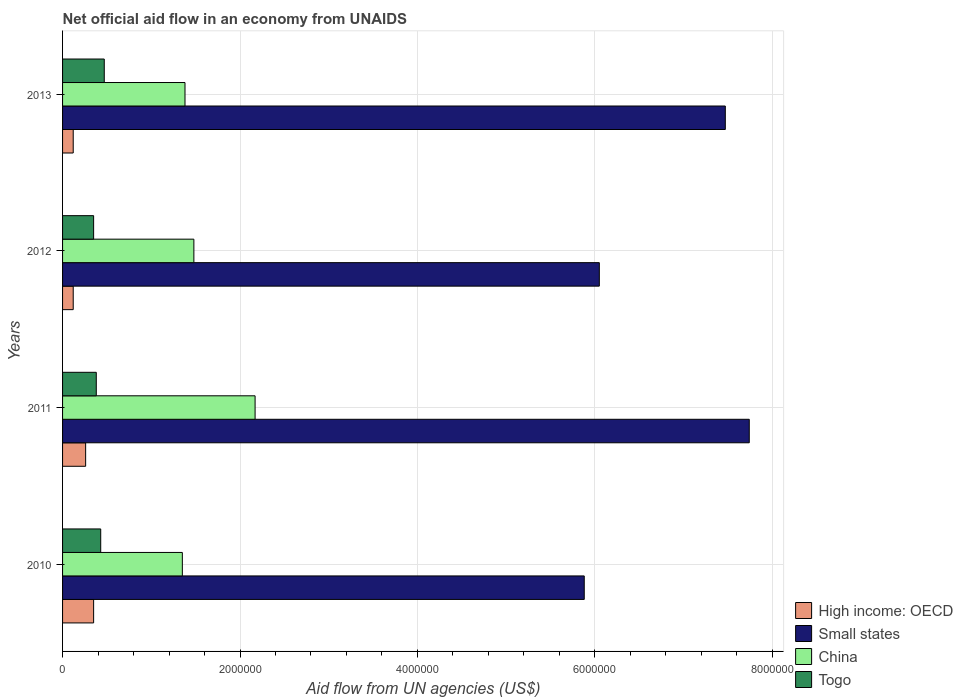Are the number of bars per tick equal to the number of legend labels?
Give a very brief answer. Yes. How many bars are there on the 1st tick from the top?
Provide a short and direct response. 4. How many bars are there on the 2nd tick from the bottom?
Provide a succinct answer. 4. In how many cases, is the number of bars for a given year not equal to the number of legend labels?
Provide a short and direct response. 0. What is the net official aid flow in High income: OECD in 2011?
Keep it short and to the point. 2.60e+05. Across all years, what is the maximum net official aid flow in High income: OECD?
Your answer should be compact. 3.50e+05. Across all years, what is the minimum net official aid flow in High income: OECD?
Your answer should be very brief. 1.20e+05. In which year was the net official aid flow in Small states maximum?
Ensure brevity in your answer.  2011. What is the total net official aid flow in Small states in the graph?
Your answer should be very brief. 2.71e+07. What is the difference between the net official aid flow in China in 2010 and that in 2012?
Ensure brevity in your answer.  -1.30e+05. What is the difference between the net official aid flow in Togo in 2011 and the net official aid flow in Small states in 2012?
Provide a succinct answer. -5.67e+06. What is the average net official aid flow in China per year?
Make the answer very short. 1.60e+06. In the year 2011, what is the difference between the net official aid flow in China and net official aid flow in High income: OECD?
Your answer should be very brief. 1.91e+06. What is the ratio of the net official aid flow in Small states in 2011 to that in 2012?
Your response must be concise. 1.28. What is the difference between the highest and the second highest net official aid flow in High income: OECD?
Offer a terse response. 9.00e+04. What is the difference between the highest and the lowest net official aid flow in China?
Offer a very short reply. 8.20e+05. Is it the case that in every year, the sum of the net official aid flow in Togo and net official aid flow in Small states is greater than the sum of net official aid flow in High income: OECD and net official aid flow in China?
Your answer should be compact. Yes. What does the 1st bar from the top in 2012 represents?
Keep it short and to the point. Togo. What does the 2nd bar from the bottom in 2012 represents?
Make the answer very short. Small states. Are all the bars in the graph horizontal?
Provide a short and direct response. Yes. How many years are there in the graph?
Give a very brief answer. 4. What is the difference between two consecutive major ticks on the X-axis?
Keep it short and to the point. 2.00e+06. Does the graph contain any zero values?
Keep it short and to the point. No. Does the graph contain grids?
Your response must be concise. Yes. Where does the legend appear in the graph?
Keep it short and to the point. Bottom right. How many legend labels are there?
Your response must be concise. 4. What is the title of the graph?
Provide a succinct answer. Net official aid flow in an economy from UNAIDS. What is the label or title of the X-axis?
Give a very brief answer. Aid flow from UN agencies (US$). What is the Aid flow from UN agencies (US$) in Small states in 2010?
Your answer should be very brief. 5.88e+06. What is the Aid flow from UN agencies (US$) of China in 2010?
Your response must be concise. 1.35e+06. What is the Aid flow from UN agencies (US$) in Togo in 2010?
Ensure brevity in your answer.  4.30e+05. What is the Aid flow from UN agencies (US$) in Small states in 2011?
Provide a short and direct response. 7.74e+06. What is the Aid flow from UN agencies (US$) of China in 2011?
Offer a very short reply. 2.17e+06. What is the Aid flow from UN agencies (US$) in Small states in 2012?
Give a very brief answer. 6.05e+06. What is the Aid flow from UN agencies (US$) of China in 2012?
Ensure brevity in your answer.  1.48e+06. What is the Aid flow from UN agencies (US$) of Small states in 2013?
Make the answer very short. 7.47e+06. What is the Aid flow from UN agencies (US$) in China in 2013?
Your answer should be compact. 1.38e+06. Across all years, what is the maximum Aid flow from UN agencies (US$) in High income: OECD?
Provide a succinct answer. 3.50e+05. Across all years, what is the maximum Aid flow from UN agencies (US$) of Small states?
Your answer should be compact. 7.74e+06. Across all years, what is the maximum Aid flow from UN agencies (US$) of China?
Keep it short and to the point. 2.17e+06. Across all years, what is the minimum Aid flow from UN agencies (US$) of High income: OECD?
Make the answer very short. 1.20e+05. Across all years, what is the minimum Aid flow from UN agencies (US$) of Small states?
Keep it short and to the point. 5.88e+06. Across all years, what is the minimum Aid flow from UN agencies (US$) of China?
Ensure brevity in your answer.  1.35e+06. Across all years, what is the minimum Aid flow from UN agencies (US$) in Togo?
Provide a short and direct response. 3.50e+05. What is the total Aid flow from UN agencies (US$) in High income: OECD in the graph?
Provide a short and direct response. 8.50e+05. What is the total Aid flow from UN agencies (US$) in Small states in the graph?
Provide a succinct answer. 2.71e+07. What is the total Aid flow from UN agencies (US$) in China in the graph?
Keep it short and to the point. 6.38e+06. What is the total Aid flow from UN agencies (US$) of Togo in the graph?
Ensure brevity in your answer.  1.63e+06. What is the difference between the Aid flow from UN agencies (US$) in High income: OECD in 2010 and that in 2011?
Keep it short and to the point. 9.00e+04. What is the difference between the Aid flow from UN agencies (US$) in Small states in 2010 and that in 2011?
Give a very brief answer. -1.86e+06. What is the difference between the Aid flow from UN agencies (US$) in China in 2010 and that in 2011?
Provide a succinct answer. -8.20e+05. What is the difference between the Aid flow from UN agencies (US$) in Togo in 2010 and that in 2011?
Provide a short and direct response. 5.00e+04. What is the difference between the Aid flow from UN agencies (US$) in Small states in 2010 and that in 2012?
Your answer should be compact. -1.70e+05. What is the difference between the Aid flow from UN agencies (US$) in China in 2010 and that in 2012?
Offer a terse response. -1.30e+05. What is the difference between the Aid flow from UN agencies (US$) in High income: OECD in 2010 and that in 2013?
Make the answer very short. 2.30e+05. What is the difference between the Aid flow from UN agencies (US$) of Small states in 2010 and that in 2013?
Provide a short and direct response. -1.59e+06. What is the difference between the Aid flow from UN agencies (US$) in High income: OECD in 2011 and that in 2012?
Ensure brevity in your answer.  1.40e+05. What is the difference between the Aid flow from UN agencies (US$) of Small states in 2011 and that in 2012?
Keep it short and to the point. 1.69e+06. What is the difference between the Aid flow from UN agencies (US$) in China in 2011 and that in 2012?
Provide a succinct answer. 6.90e+05. What is the difference between the Aid flow from UN agencies (US$) of High income: OECD in 2011 and that in 2013?
Provide a succinct answer. 1.40e+05. What is the difference between the Aid flow from UN agencies (US$) in Small states in 2011 and that in 2013?
Your response must be concise. 2.70e+05. What is the difference between the Aid flow from UN agencies (US$) in China in 2011 and that in 2013?
Provide a short and direct response. 7.90e+05. What is the difference between the Aid flow from UN agencies (US$) in Togo in 2011 and that in 2013?
Offer a very short reply. -9.00e+04. What is the difference between the Aid flow from UN agencies (US$) of High income: OECD in 2012 and that in 2013?
Provide a short and direct response. 0. What is the difference between the Aid flow from UN agencies (US$) in Small states in 2012 and that in 2013?
Offer a terse response. -1.42e+06. What is the difference between the Aid flow from UN agencies (US$) in China in 2012 and that in 2013?
Make the answer very short. 1.00e+05. What is the difference between the Aid flow from UN agencies (US$) in Togo in 2012 and that in 2013?
Make the answer very short. -1.20e+05. What is the difference between the Aid flow from UN agencies (US$) in High income: OECD in 2010 and the Aid flow from UN agencies (US$) in Small states in 2011?
Offer a very short reply. -7.39e+06. What is the difference between the Aid flow from UN agencies (US$) in High income: OECD in 2010 and the Aid flow from UN agencies (US$) in China in 2011?
Your answer should be very brief. -1.82e+06. What is the difference between the Aid flow from UN agencies (US$) in Small states in 2010 and the Aid flow from UN agencies (US$) in China in 2011?
Your response must be concise. 3.71e+06. What is the difference between the Aid flow from UN agencies (US$) in Small states in 2010 and the Aid flow from UN agencies (US$) in Togo in 2011?
Offer a very short reply. 5.50e+06. What is the difference between the Aid flow from UN agencies (US$) of China in 2010 and the Aid flow from UN agencies (US$) of Togo in 2011?
Offer a terse response. 9.70e+05. What is the difference between the Aid flow from UN agencies (US$) in High income: OECD in 2010 and the Aid flow from UN agencies (US$) in Small states in 2012?
Provide a succinct answer. -5.70e+06. What is the difference between the Aid flow from UN agencies (US$) in High income: OECD in 2010 and the Aid flow from UN agencies (US$) in China in 2012?
Give a very brief answer. -1.13e+06. What is the difference between the Aid flow from UN agencies (US$) in Small states in 2010 and the Aid flow from UN agencies (US$) in China in 2012?
Ensure brevity in your answer.  4.40e+06. What is the difference between the Aid flow from UN agencies (US$) in Small states in 2010 and the Aid flow from UN agencies (US$) in Togo in 2012?
Ensure brevity in your answer.  5.53e+06. What is the difference between the Aid flow from UN agencies (US$) of China in 2010 and the Aid flow from UN agencies (US$) of Togo in 2012?
Offer a very short reply. 1.00e+06. What is the difference between the Aid flow from UN agencies (US$) of High income: OECD in 2010 and the Aid flow from UN agencies (US$) of Small states in 2013?
Keep it short and to the point. -7.12e+06. What is the difference between the Aid flow from UN agencies (US$) in High income: OECD in 2010 and the Aid flow from UN agencies (US$) in China in 2013?
Provide a succinct answer. -1.03e+06. What is the difference between the Aid flow from UN agencies (US$) in High income: OECD in 2010 and the Aid flow from UN agencies (US$) in Togo in 2013?
Your answer should be compact. -1.20e+05. What is the difference between the Aid flow from UN agencies (US$) in Small states in 2010 and the Aid flow from UN agencies (US$) in China in 2013?
Provide a succinct answer. 4.50e+06. What is the difference between the Aid flow from UN agencies (US$) of Small states in 2010 and the Aid flow from UN agencies (US$) of Togo in 2013?
Give a very brief answer. 5.41e+06. What is the difference between the Aid flow from UN agencies (US$) of China in 2010 and the Aid flow from UN agencies (US$) of Togo in 2013?
Your response must be concise. 8.80e+05. What is the difference between the Aid flow from UN agencies (US$) of High income: OECD in 2011 and the Aid flow from UN agencies (US$) of Small states in 2012?
Provide a succinct answer. -5.79e+06. What is the difference between the Aid flow from UN agencies (US$) in High income: OECD in 2011 and the Aid flow from UN agencies (US$) in China in 2012?
Provide a succinct answer. -1.22e+06. What is the difference between the Aid flow from UN agencies (US$) in Small states in 2011 and the Aid flow from UN agencies (US$) in China in 2012?
Give a very brief answer. 6.26e+06. What is the difference between the Aid flow from UN agencies (US$) of Small states in 2011 and the Aid flow from UN agencies (US$) of Togo in 2012?
Provide a short and direct response. 7.39e+06. What is the difference between the Aid flow from UN agencies (US$) in China in 2011 and the Aid flow from UN agencies (US$) in Togo in 2012?
Ensure brevity in your answer.  1.82e+06. What is the difference between the Aid flow from UN agencies (US$) in High income: OECD in 2011 and the Aid flow from UN agencies (US$) in Small states in 2013?
Your answer should be compact. -7.21e+06. What is the difference between the Aid flow from UN agencies (US$) in High income: OECD in 2011 and the Aid flow from UN agencies (US$) in China in 2013?
Ensure brevity in your answer.  -1.12e+06. What is the difference between the Aid flow from UN agencies (US$) of High income: OECD in 2011 and the Aid flow from UN agencies (US$) of Togo in 2013?
Your answer should be very brief. -2.10e+05. What is the difference between the Aid flow from UN agencies (US$) of Small states in 2011 and the Aid flow from UN agencies (US$) of China in 2013?
Your answer should be very brief. 6.36e+06. What is the difference between the Aid flow from UN agencies (US$) in Small states in 2011 and the Aid flow from UN agencies (US$) in Togo in 2013?
Give a very brief answer. 7.27e+06. What is the difference between the Aid flow from UN agencies (US$) of China in 2011 and the Aid flow from UN agencies (US$) of Togo in 2013?
Your answer should be compact. 1.70e+06. What is the difference between the Aid flow from UN agencies (US$) of High income: OECD in 2012 and the Aid flow from UN agencies (US$) of Small states in 2013?
Provide a succinct answer. -7.35e+06. What is the difference between the Aid flow from UN agencies (US$) of High income: OECD in 2012 and the Aid flow from UN agencies (US$) of China in 2013?
Your response must be concise. -1.26e+06. What is the difference between the Aid flow from UN agencies (US$) in High income: OECD in 2012 and the Aid flow from UN agencies (US$) in Togo in 2013?
Provide a succinct answer. -3.50e+05. What is the difference between the Aid flow from UN agencies (US$) in Small states in 2012 and the Aid flow from UN agencies (US$) in China in 2013?
Your answer should be very brief. 4.67e+06. What is the difference between the Aid flow from UN agencies (US$) of Small states in 2012 and the Aid flow from UN agencies (US$) of Togo in 2013?
Your answer should be very brief. 5.58e+06. What is the difference between the Aid flow from UN agencies (US$) in China in 2012 and the Aid flow from UN agencies (US$) in Togo in 2013?
Your answer should be compact. 1.01e+06. What is the average Aid flow from UN agencies (US$) in High income: OECD per year?
Ensure brevity in your answer.  2.12e+05. What is the average Aid flow from UN agencies (US$) of Small states per year?
Ensure brevity in your answer.  6.78e+06. What is the average Aid flow from UN agencies (US$) in China per year?
Ensure brevity in your answer.  1.60e+06. What is the average Aid flow from UN agencies (US$) of Togo per year?
Ensure brevity in your answer.  4.08e+05. In the year 2010, what is the difference between the Aid flow from UN agencies (US$) in High income: OECD and Aid flow from UN agencies (US$) in Small states?
Ensure brevity in your answer.  -5.53e+06. In the year 2010, what is the difference between the Aid flow from UN agencies (US$) of High income: OECD and Aid flow from UN agencies (US$) of China?
Provide a succinct answer. -1.00e+06. In the year 2010, what is the difference between the Aid flow from UN agencies (US$) of High income: OECD and Aid flow from UN agencies (US$) of Togo?
Ensure brevity in your answer.  -8.00e+04. In the year 2010, what is the difference between the Aid flow from UN agencies (US$) of Small states and Aid flow from UN agencies (US$) of China?
Keep it short and to the point. 4.53e+06. In the year 2010, what is the difference between the Aid flow from UN agencies (US$) in Small states and Aid flow from UN agencies (US$) in Togo?
Give a very brief answer. 5.45e+06. In the year 2010, what is the difference between the Aid flow from UN agencies (US$) in China and Aid flow from UN agencies (US$) in Togo?
Make the answer very short. 9.20e+05. In the year 2011, what is the difference between the Aid flow from UN agencies (US$) in High income: OECD and Aid flow from UN agencies (US$) in Small states?
Provide a succinct answer. -7.48e+06. In the year 2011, what is the difference between the Aid flow from UN agencies (US$) of High income: OECD and Aid flow from UN agencies (US$) of China?
Give a very brief answer. -1.91e+06. In the year 2011, what is the difference between the Aid flow from UN agencies (US$) of High income: OECD and Aid flow from UN agencies (US$) of Togo?
Your response must be concise. -1.20e+05. In the year 2011, what is the difference between the Aid flow from UN agencies (US$) of Small states and Aid flow from UN agencies (US$) of China?
Your answer should be compact. 5.57e+06. In the year 2011, what is the difference between the Aid flow from UN agencies (US$) of Small states and Aid flow from UN agencies (US$) of Togo?
Give a very brief answer. 7.36e+06. In the year 2011, what is the difference between the Aid flow from UN agencies (US$) in China and Aid flow from UN agencies (US$) in Togo?
Make the answer very short. 1.79e+06. In the year 2012, what is the difference between the Aid flow from UN agencies (US$) of High income: OECD and Aid flow from UN agencies (US$) of Small states?
Offer a terse response. -5.93e+06. In the year 2012, what is the difference between the Aid flow from UN agencies (US$) in High income: OECD and Aid flow from UN agencies (US$) in China?
Make the answer very short. -1.36e+06. In the year 2012, what is the difference between the Aid flow from UN agencies (US$) in High income: OECD and Aid flow from UN agencies (US$) in Togo?
Offer a terse response. -2.30e+05. In the year 2012, what is the difference between the Aid flow from UN agencies (US$) of Small states and Aid flow from UN agencies (US$) of China?
Offer a terse response. 4.57e+06. In the year 2012, what is the difference between the Aid flow from UN agencies (US$) of Small states and Aid flow from UN agencies (US$) of Togo?
Keep it short and to the point. 5.70e+06. In the year 2012, what is the difference between the Aid flow from UN agencies (US$) of China and Aid flow from UN agencies (US$) of Togo?
Offer a terse response. 1.13e+06. In the year 2013, what is the difference between the Aid flow from UN agencies (US$) in High income: OECD and Aid flow from UN agencies (US$) in Small states?
Your answer should be compact. -7.35e+06. In the year 2013, what is the difference between the Aid flow from UN agencies (US$) of High income: OECD and Aid flow from UN agencies (US$) of China?
Your response must be concise. -1.26e+06. In the year 2013, what is the difference between the Aid flow from UN agencies (US$) of High income: OECD and Aid flow from UN agencies (US$) of Togo?
Your response must be concise. -3.50e+05. In the year 2013, what is the difference between the Aid flow from UN agencies (US$) in Small states and Aid flow from UN agencies (US$) in China?
Your response must be concise. 6.09e+06. In the year 2013, what is the difference between the Aid flow from UN agencies (US$) of China and Aid flow from UN agencies (US$) of Togo?
Keep it short and to the point. 9.10e+05. What is the ratio of the Aid flow from UN agencies (US$) of High income: OECD in 2010 to that in 2011?
Make the answer very short. 1.35. What is the ratio of the Aid flow from UN agencies (US$) of Small states in 2010 to that in 2011?
Your answer should be very brief. 0.76. What is the ratio of the Aid flow from UN agencies (US$) in China in 2010 to that in 2011?
Provide a short and direct response. 0.62. What is the ratio of the Aid flow from UN agencies (US$) of Togo in 2010 to that in 2011?
Make the answer very short. 1.13. What is the ratio of the Aid flow from UN agencies (US$) of High income: OECD in 2010 to that in 2012?
Make the answer very short. 2.92. What is the ratio of the Aid flow from UN agencies (US$) in Small states in 2010 to that in 2012?
Your response must be concise. 0.97. What is the ratio of the Aid flow from UN agencies (US$) of China in 2010 to that in 2012?
Keep it short and to the point. 0.91. What is the ratio of the Aid flow from UN agencies (US$) of Togo in 2010 to that in 2012?
Ensure brevity in your answer.  1.23. What is the ratio of the Aid flow from UN agencies (US$) in High income: OECD in 2010 to that in 2013?
Provide a succinct answer. 2.92. What is the ratio of the Aid flow from UN agencies (US$) of Small states in 2010 to that in 2013?
Provide a short and direct response. 0.79. What is the ratio of the Aid flow from UN agencies (US$) of China in 2010 to that in 2013?
Your answer should be compact. 0.98. What is the ratio of the Aid flow from UN agencies (US$) in Togo in 2010 to that in 2013?
Your response must be concise. 0.91. What is the ratio of the Aid flow from UN agencies (US$) of High income: OECD in 2011 to that in 2012?
Keep it short and to the point. 2.17. What is the ratio of the Aid flow from UN agencies (US$) in Small states in 2011 to that in 2012?
Offer a terse response. 1.28. What is the ratio of the Aid flow from UN agencies (US$) in China in 2011 to that in 2012?
Your answer should be very brief. 1.47. What is the ratio of the Aid flow from UN agencies (US$) of Togo in 2011 to that in 2012?
Give a very brief answer. 1.09. What is the ratio of the Aid flow from UN agencies (US$) in High income: OECD in 2011 to that in 2013?
Offer a terse response. 2.17. What is the ratio of the Aid flow from UN agencies (US$) of Small states in 2011 to that in 2013?
Keep it short and to the point. 1.04. What is the ratio of the Aid flow from UN agencies (US$) of China in 2011 to that in 2013?
Your response must be concise. 1.57. What is the ratio of the Aid flow from UN agencies (US$) of Togo in 2011 to that in 2013?
Give a very brief answer. 0.81. What is the ratio of the Aid flow from UN agencies (US$) of Small states in 2012 to that in 2013?
Provide a succinct answer. 0.81. What is the ratio of the Aid flow from UN agencies (US$) in China in 2012 to that in 2013?
Provide a succinct answer. 1.07. What is the ratio of the Aid flow from UN agencies (US$) of Togo in 2012 to that in 2013?
Your answer should be compact. 0.74. What is the difference between the highest and the second highest Aid flow from UN agencies (US$) of Small states?
Give a very brief answer. 2.70e+05. What is the difference between the highest and the second highest Aid flow from UN agencies (US$) of China?
Provide a short and direct response. 6.90e+05. What is the difference between the highest and the lowest Aid flow from UN agencies (US$) of High income: OECD?
Provide a short and direct response. 2.30e+05. What is the difference between the highest and the lowest Aid flow from UN agencies (US$) of Small states?
Give a very brief answer. 1.86e+06. What is the difference between the highest and the lowest Aid flow from UN agencies (US$) in China?
Your answer should be very brief. 8.20e+05. 